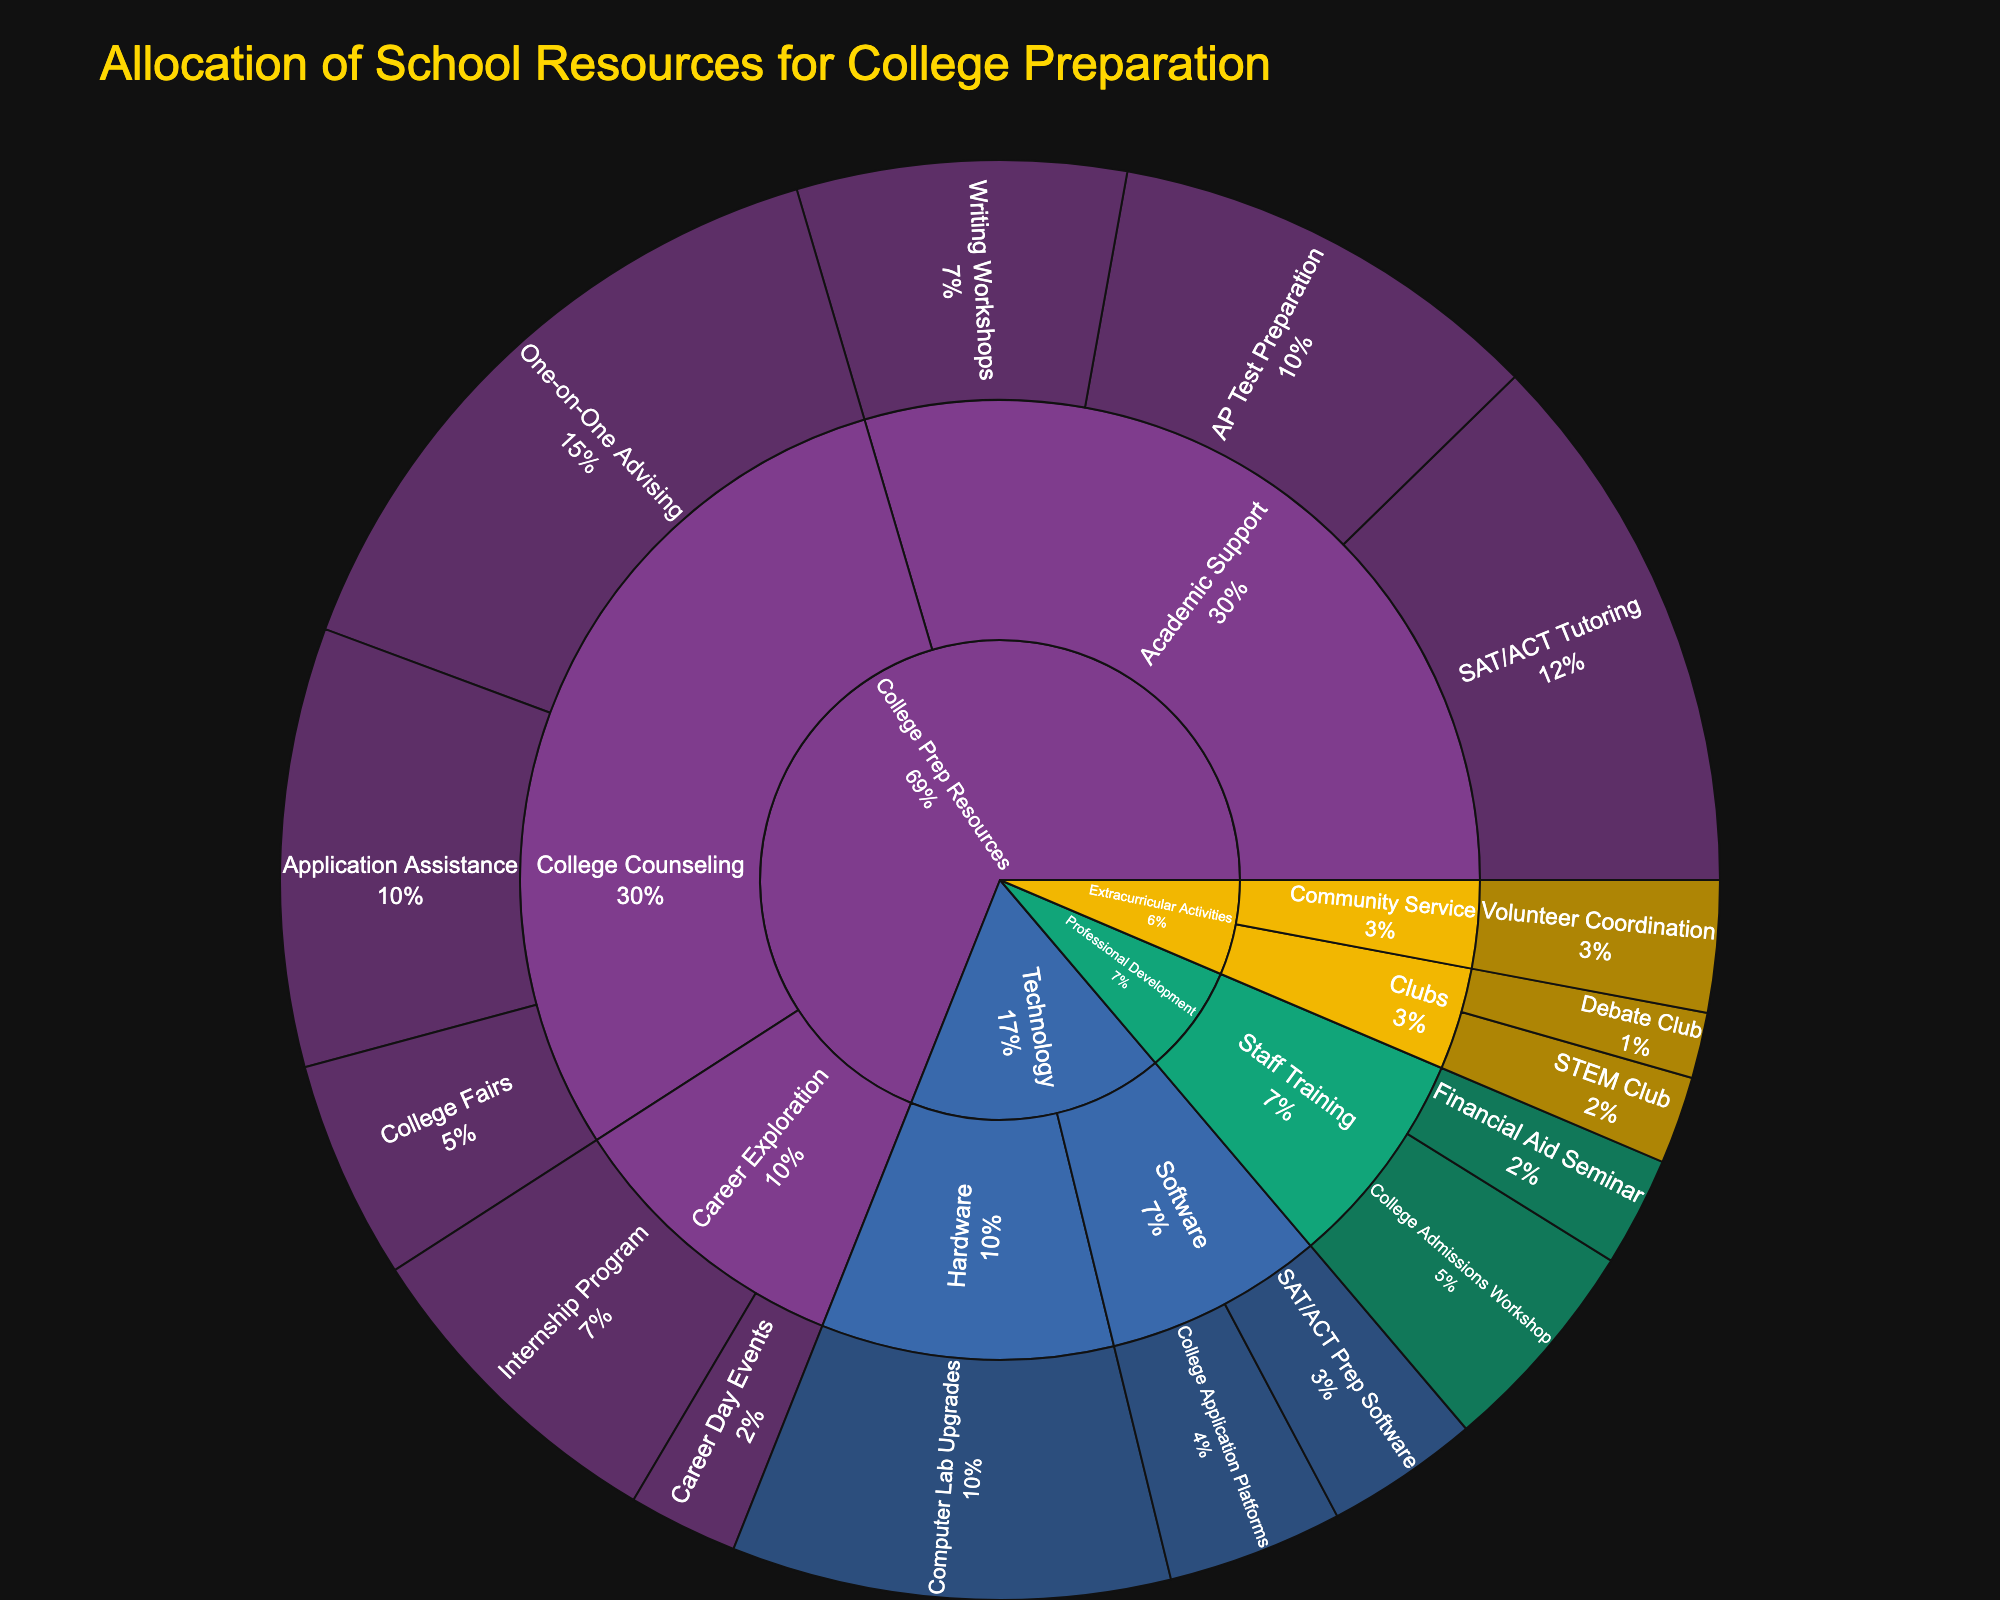What's the total allocation for College Prep Resources? To find the total allocation for College Prep Resources, sum up the allocations of all its subcategories and programs. The amounts are $25,000, $20,000, $15,000, $30,000, $10,000, $20,000, $15,000, and $5,000. The total is $25,000 + $20,000 + $15,000 + $30,000 + $10,000 + $20,000 + $15,000 + $5,000 = $140,000.
Answer: $140,000 Which subcategory within College Prep Resources has the highest allocation? Within College Prep Resources, we compare the totals for Academic Support ($25,000 + $20,000 + $15,000 = $60,000), College Counseling ($30,000 + $10,000 + $20,000 = $60,000), and Career Exploration ($15,000 + $5,000 = $20,000). Both Academic Support and College Counseling sum to $60,000, which is the highest allocation.
Answer: Academic Support and College Counseling How does the allocation for SAT/ACT Tutoring compare to Computer Lab Upgrades? The allocation for SAT/ACT Tutoring is $25,000, while the allocation for Computer Lab Upgrades is $20,000. By comparing the two amounts, we see that SAT/ACT Tutoring has a higher allocation.
Answer: SAT/ACT Tutoring has a higher allocation What is the total allocation for Technology? To find the total allocation for Technology, sum up the allocations for each program: College Application Platforms ($8,000), SAT/ACT Prep Software ($7,000), and Computer Lab Upgrades ($20,000). The total is $8,000 + $7,000 + $20,000 = $35,000.
Answer: $35,000 Which has a larger allocation: Extracurricular Activities or Professional Development? For Extracurricular Activities, sum the allocations for all programs: Debate Club ($3,000), STEM Club ($4,000), and Volunteer Coordination ($6,000). Total is $3,000 + $4,000 + $6,000 = $13,000. For Professional Development, sum the allocations for both programs: College Admissions Workshop ($10,000) and Financial Aid Seminar ($5,000). Total is $10,000 + $5,000 = $15,000. Comparing these totals, Professional Development has a larger allocation.
Answer: Professional Development What is the total allocation for Career Exploration within College Prep Resources? Career Exploration includes the programs Internship Program ($15,000) and Career Day Events ($5,000). Summing these gives $15,000 + $5,000 = $20,000.
Answer: $20,000 Which College Counseling program has the lowest allocation? The College Counseling programs are One-on-One Advising ($30,000), College Fairs ($10,000), and Application Assistance ($20,000). The lowest allocation among these is College Fairs at $10,000.
Answer: College Fairs What percentage of the total allocation is directed towards SAT/ACT Tutoring? First, calculate the total allocation across all categories: $250,000 (sum of all allocations). Then, find the percentage of the allocation for SAT/ACT Tutoring ($25,000). The percentage is ($25,000 / $250,000) * 100 = 10%.
Answer: 10% 